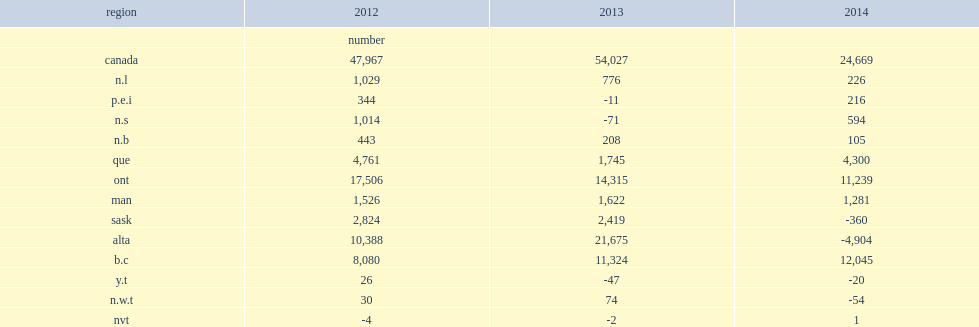In 2014, what was the net number of non-permanent residents? 24669.0. In 2013, what was the net number of non-permanent residents? 54027.0. In 2014, what was the net number of non-permanent residents in manitoba? 1281.0. In 2014, what was the net number of non-permanent residents in british columbia? 12045.0. 